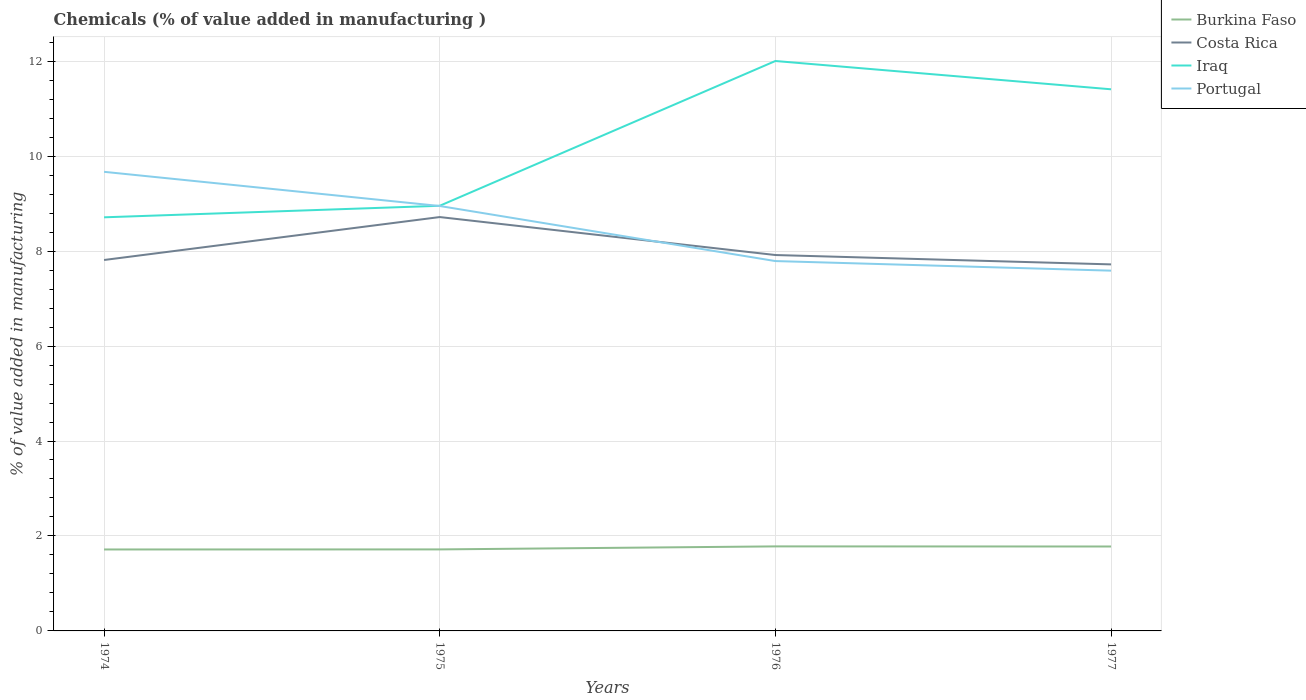Across all years, what is the maximum value added in manufacturing chemicals in Burkina Faso?
Ensure brevity in your answer.  1.72. In which year was the value added in manufacturing chemicals in Portugal maximum?
Offer a very short reply. 1977. What is the total value added in manufacturing chemicals in Iraq in the graph?
Ensure brevity in your answer.  0.6. What is the difference between the highest and the second highest value added in manufacturing chemicals in Iraq?
Your answer should be compact. 3.29. What is the difference between the highest and the lowest value added in manufacturing chemicals in Burkina Faso?
Your answer should be compact. 2. Are the values on the major ticks of Y-axis written in scientific E-notation?
Offer a terse response. No. Does the graph contain any zero values?
Make the answer very short. No. Where does the legend appear in the graph?
Your answer should be very brief. Top right. What is the title of the graph?
Give a very brief answer. Chemicals (% of value added in manufacturing ). What is the label or title of the X-axis?
Your answer should be compact. Years. What is the label or title of the Y-axis?
Make the answer very short. % of value added in manufacturing. What is the % of value added in manufacturing in Burkina Faso in 1974?
Keep it short and to the point. 1.72. What is the % of value added in manufacturing of Costa Rica in 1974?
Provide a succinct answer. 7.81. What is the % of value added in manufacturing of Iraq in 1974?
Keep it short and to the point. 8.71. What is the % of value added in manufacturing of Portugal in 1974?
Your answer should be compact. 9.67. What is the % of value added in manufacturing in Burkina Faso in 1975?
Your response must be concise. 1.72. What is the % of value added in manufacturing of Costa Rica in 1975?
Your answer should be very brief. 8.72. What is the % of value added in manufacturing in Iraq in 1975?
Your answer should be compact. 8.95. What is the % of value added in manufacturing of Portugal in 1975?
Provide a succinct answer. 8.95. What is the % of value added in manufacturing in Burkina Faso in 1976?
Provide a short and direct response. 1.78. What is the % of value added in manufacturing of Costa Rica in 1976?
Provide a succinct answer. 7.92. What is the % of value added in manufacturing in Iraq in 1976?
Provide a short and direct response. 12. What is the % of value added in manufacturing of Portugal in 1976?
Your answer should be very brief. 7.79. What is the % of value added in manufacturing in Burkina Faso in 1977?
Provide a succinct answer. 1.78. What is the % of value added in manufacturing of Costa Rica in 1977?
Offer a terse response. 7.72. What is the % of value added in manufacturing in Iraq in 1977?
Offer a very short reply. 11.41. What is the % of value added in manufacturing of Portugal in 1977?
Keep it short and to the point. 7.59. Across all years, what is the maximum % of value added in manufacturing of Burkina Faso?
Provide a succinct answer. 1.78. Across all years, what is the maximum % of value added in manufacturing in Costa Rica?
Keep it short and to the point. 8.72. Across all years, what is the maximum % of value added in manufacturing of Iraq?
Make the answer very short. 12. Across all years, what is the maximum % of value added in manufacturing of Portugal?
Your response must be concise. 9.67. Across all years, what is the minimum % of value added in manufacturing in Burkina Faso?
Provide a short and direct response. 1.72. Across all years, what is the minimum % of value added in manufacturing in Costa Rica?
Ensure brevity in your answer.  7.72. Across all years, what is the minimum % of value added in manufacturing in Iraq?
Give a very brief answer. 8.71. Across all years, what is the minimum % of value added in manufacturing of Portugal?
Your response must be concise. 7.59. What is the total % of value added in manufacturing in Burkina Faso in the graph?
Your answer should be very brief. 6.99. What is the total % of value added in manufacturing of Costa Rica in the graph?
Your answer should be very brief. 32.17. What is the total % of value added in manufacturing in Iraq in the graph?
Provide a succinct answer. 41.08. What is the total % of value added in manufacturing of Portugal in the graph?
Keep it short and to the point. 34. What is the difference between the % of value added in manufacturing in Burkina Faso in 1974 and that in 1975?
Offer a terse response. -0. What is the difference between the % of value added in manufacturing in Costa Rica in 1974 and that in 1975?
Provide a short and direct response. -0.9. What is the difference between the % of value added in manufacturing of Iraq in 1974 and that in 1975?
Offer a very short reply. -0.24. What is the difference between the % of value added in manufacturing in Portugal in 1974 and that in 1975?
Your answer should be very brief. 0.72. What is the difference between the % of value added in manufacturing of Burkina Faso in 1974 and that in 1976?
Provide a succinct answer. -0.06. What is the difference between the % of value added in manufacturing of Costa Rica in 1974 and that in 1976?
Keep it short and to the point. -0.1. What is the difference between the % of value added in manufacturing of Iraq in 1974 and that in 1976?
Provide a short and direct response. -3.29. What is the difference between the % of value added in manufacturing of Portugal in 1974 and that in 1976?
Your answer should be very brief. 1.88. What is the difference between the % of value added in manufacturing of Burkina Faso in 1974 and that in 1977?
Offer a very short reply. -0.06. What is the difference between the % of value added in manufacturing of Costa Rica in 1974 and that in 1977?
Make the answer very short. 0.09. What is the difference between the % of value added in manufacturing of Iraq in 1974 and that in 1977?
Offer a very short reply. -2.7. What is the difference between the % of value added in manufacturing of Portugal in 1974 and that in 1977?
Keep it short and to the point. 2.08. What is the difference between the % of value added in manufacturing of Burkina Faso in 1975 and that in 1976?
Your response must be concise. -0.06. What is the difference between the % of value added in manufacturing of Costa Rica in 1975 and that in 1976?
Provide a short and direct response. 0.8. What is the difference between the % of value added in manufacturing of Iraq in 1975 and that in 1976?
Keep it short and to the point. -3.05. What is the difference between the % of value added in manufacturing in Portugal in 1975 and that in 1976?
Provide a short and direct response. 1.16. What is the difference between the % of value added in manufacturing in Burkina Faso in 1975 and that in 1977?
Offer a very short reply. -0.06. What is the difference between the % of value added in manufacturing in Iraq in 1975 and that in 1977?
Your answer should be compact. -2.45. What is the difference between the % of value added in manufacturing in Portugal in 1975 and that in 1977?
Your answer should be very brief. 1.36. What is the difference between the % of value added in manufacturing in Burkina Faso in 1976 and that in 1977?
Offer a terse response. 0. What is the difference between the % of value added in manufacturing in Costa Rica in 1976 and that in 1977?
Your answer should be compact. 0.2. What is the difference between the % of value added in manufacturing in Iraq in 1976 and that in 1977?
Give a very brief answer. 0.6. What is the difference between the % of value added in manufacturing in Portugal in 1976 and that in 1977?
Ensure brevity in your answer.  0.2. What is the difference between the % of value added in manufacturing of Burkina Faso in 1974 and the % of value added in manufacturing of Costa Rica in 1975?
Provide a short and direct response. -7. What is the difference between the % of value added in manufacturing of Burkina Faso in 1974 and the % of value added in manufacturing of Iraq in 1975?
Provide a short and direct response. -7.24. What is the difference between the % of value added in manufacturing of Burkina Faso in 1974 and the % of value added in manufacturing of Portugal in 1975?
Keep it short and to the point. -7.23. What is the difference between the % of value added in manufacturing of Costa Rica in 1974 and the % of value added in manufacturing of Iraq in 1975?
Provide a short and direct response. -1.14. What is the difference between the % of value added in manufacturing in Costa Rica in 1974 and the % of value added in manufacturing in Portugal in 1975?
Your answer should be very brief. -1.14. What is the difference between the % of value added in manufacturing of Iraq in 1974 and the % of value added in manufacturing of Portugal in 1975?
Give a very brief answer. -0.24. What is the difference between the % of value added in manufacturing of Burkina Faso in 1974 and the % of value added in manufacturing of Costa Rica in 1976?
Keep it short and to the point. -6.2. What is the difference between the % of value added in manufacturing of Burkina Faso in 1974 and the % of value added in manufacturing of Iraq in 1976?
Offer a terse response. -10.29. What is the difference between the % of value added in manufacturing of Burkina Faso in 1974 and the % of value added in manufacturing of Portugal in 1976?
Your answer should be compact. -6.07. What is the difference between the % of value added in manufacturing in Costa Rica in 1974 and the % of value added in manufacturing in Iraq in 1976?
Your answer should be compact. -4.19. What is the difference between the % of value added in manufacturing in Costa Rica in 1974 and the % of value added in manufacturing in Portugal in 1976?
Make the answer very short. 0.02. What is the difference between the % of value added in manufacturing of Iraq in 1974 and the % of value added in manufacturing of Portugal in 1976?
Provide a short and direct response. 0.92. What is the difference between the % of value added in manufacturing in Burkina Faso in 1974 and the % of value added in manufacturing in Costa Rica in 1977?
Your response must be concise. -6. What is the difference between the % of value added in manufacturing of Burkina Faso in 1974 and the % of value added in manufacturing of Iraq in 1977?
Your answer should be compact. -9.69. What is the difference between the % of value added in manufacturing of Burkina Faso in 1974 and the % of value added in manufacturing of Portugal in 1977?
Your answer should be very brief. -5.87. What is the difference between the % of value added in manufacturing of Costa Rica in 1974 and the % of value added in manufacturing of Iraq in 1977?
Provide a succinct answer. -3.6. What is the difference between the % of value added in manufacturing in Costa Rica in 1974 and the % of value added in manufacturing in Portugal in 1977?
Make the answer very short. 0.22. What is the difference between the % of value added in manufacturing of Iraq in 1974 and the % of value added in manufacturing of Portugal in 1977?
Give a very brief answer. 1.12. What is the difference between the % of value added in manufacturing in Burkina Faso in 1975 and the % of value added in manufacturing in Costa Rica in 1976?
Provide a short and direct response. -6.2. What is the difference between the % of value added in manufacturing in Burkina Faso in 1975 and the % of value added in manufacturing in Iraq in 1976?
Ensure brevity in your answer.  -10.29. What is the difference between the % of value added in manufacturing of Burkina Faso in 1975 and the % of value added in manufacturing of Portugal in 1976?
Provide a succinct answer. -6.07. What is the difference between the % of value added in manufacturing in Costa Rica in 1975 and the % of value added in manufacturing in Iraq in 1976?
Offer a very short reply. -3.29. What is the difference between the % of value added in manufacturing in Costa Rica in 1975 and the % of value added in manufacturing in Portugal in 1976?
Offer a terse response. 0.93. What is the difference between the % of value added in manufacturing in Iraq in 1975 and the % of value added in manufacturing in Portugal in 1976?
Offer a terse response. 1.16. What is the difference between the % of value added in manufacturing of Burkina Faso in 1975 and the % of value added in manufacturing of Costa Rica in 1977?
Your answer should be very brief. -6. What is the difference between the % of value added in manufacturing in Burkina Faso in 1975 and the % of value added in manufacturing in Iraq in 1977?
Offer a very short reply. -9.69. What is the difference between the % of value added in manufacturing in Burkina Faso in 1975 and the % of value added in manufacturing in Portugal in 1977?
Provide a succinct answer. -5.87. What is the difference between the % of value added in manufacturing in Costa Rica in 1975 and the % of value added in manufacturing in Iraq in 1977?
Offer a very short reply. -2.69. What is the difference between the % of value added in manufacturing in Costa Rica in 1975 and the % of value added in manufacturing in Portugal in 1977?
Your response must be concise. 1.13. What is the difference between the % of value added in manufacturing of Iraq in 1975 and the % of value added in manufacturing of Portugal in 1977?
Give a very brief answer. 1.37. What is the difference between the % of value added in manufacturing in Burkina Faso in 1976 and the % of value added in manufacturing in Costa Rica in 1977?
Provide a short and direct response. -5.94. What is the difference between the % of value added in manufacturing of Burkina Faso in 1976 and the % of value added in manufacturing of Iraq in 1977?
Offer a terse response. -9.63. What is the difference between the % of value added in manufacturing of Burkina Faso in 1976 and the % of value added in manufacturing of Portugal in 1977?
Give a very brief answer. -5.81. What is the difference between the % of value added in manufacturing in Costa Rica in 1976 and the % of value added in manufacturing in Iraq in 1977?
Offer a terse response. -3.49. What is the difference between the % of value added in manufacturing of Costa Rica in 1976 and the % of value added in manufacturing of Portugal in 1977?
Your answer should be compact. 0.33. What is the difference between the % of value added in manufacturing of Iraq in 1976 and the % of value added in manufacturing of Portugal in 1977?
Give a very brief answer. 4.42. What is the average % of value added in manufacturing in Burkina Faso per year?
Offer a terse response. 1.75. What is the average % of value added in manufacturing in Costa Rica per year?
Give a very brief answer. 8.04. What is the average % of value added in manufacturing of Iraq per year?
Make the answer very short. 10.27. What is the average % of value added in manufacturing in Portugal per year?
Provide a short and direct response. 8.5. In the year 1974, what is the difference between the % of value added in manufacturing of Burkina Faso and % of value added in manufacturing of Costa Rica?
Your answer should be very brief. -6.1. In the year 1974, what is the difference between the % of value added in manufacturing of Burkina Faso and % of value added in manufacturing of Iraq?
Make the answer very short. -7. In the year 1974, what is the difference between the % of value added in manufacturing in Burkina Faso and % of value added in manufacturing in Portugal?
Offer a terse response. -7.95. In the year 1974, what is the difference between the % of value added in manufacturing of Costa Rica and % of value added in manufacturing of Iraq?
Ensure brevity in your answer.  -0.9. In the year 1974, what is the difference between the % of value added in manufacturing in Costa Rica and % of value added in manufacturing in Portugal?
Make the answer very short. -1.86. In the year 1974, what is the difference between the % of value added in manufacturing in Iraq and % of value added in manufacturing in Portugal?
Offer a terse response. -0.96. In the year 1975, what is the difference between the % of value added in manufacturing of Burkina Faso and % of value added in manufacturing of Costa Rica?
Give a very brief answer. -7. In the year 1975, what is the difference between the % of value added in manufacturing in Burkina Faso and % of value added in manufacturing in Iraq?
Your answer should be very brief. -7.24. In the year 1975, what is the difference between the % of value added in manufacturing in Burkina Faso and % of value added in manufacturing in Portugal?
Your response must be concise. -7.23. In the year 1975, what is the difference between the % of value added in manufacturing in Costa Rica and % of value added in manufacturing in Iraq?
Provide a short and direct response. -0.24. In the year 1975, what is the difference between the % of value added in manufacturing of Costa Rica and % of value added in manufacturing of Portugal?
Provide a succinct answer. -0.23. In the year 1975, what is the difference between the % of value added in manufacturing of Iraq and % of value added in manufacturing of Portugal?
Provide a short and direct response. 0. In the year 1976, what is the difference between the % of value added in manufacturing of Burkina Faso and % of value added in manufacturing of Costa Rica?
Your response must be concise. -6.14. In the year 1976, what is the difference between the % of value added in manufacturing in Burkina Faso and % of value added in manufacturing in Iraq?
Your response must be concise. -10.22. In the year 1976, what is the difference between the % of value added in manufacturing in Burkina Faso and % of value added in manufacturing in Portugal?
Your answer should be very brief. -6.01. In the year 1976, what is the difference between the % of value added in manufacturing of Costa Rica and % of value added in manufacturing of Iraq?
Give a very brief answer. -4.09. In the year 1976, what is the difference between the % of value added in manufacturing of Costa Rica and % of value added in manufacturing of Portugal?
Offer a terse response. 0.13. In the year 1976, what is the difference between the % of value added in manufacturing of Iraq and % of value added in manufacturing of Portugal?
Your response must be concise. 4.21. In the year 1977, what is the difference between the % of value added in manufacturing in Burkina Faso and % of value added in manufacturing in Costa Rica?
Give a very brief answer. -5.94. In the year 1977, what is the difference between the % of value added in manufacturing of Burkina Faso and % of value added in manufacturing of Iraq?
Provide a short and direct response. -9.63. In the year 1977, what is the difference between the % of value added in manufacturing in Burkina Faso and % of value added in manufacturing in Portugal?
Make the answer very short. -5.81. In the year 1977, what is the difference between the % of value added in manufacturing of Costa Rica and % of value added in manufacturing of Iraq?
Give a very brief answer. -3.69. In the year 1977, what is the difference between the % of value added in manufacturing of Costa Rica and % of value added in manufacturing of Portugal?
Make the answer very short. 0.13. In the year 1977, what is the difference between the % of value added in manufacturing of Iraq and % of value added in manufacturing of Portugal?
Offer a terse response. 3.82. What is the ratio of the % of value added in manufacturing in Burkina Faso in 1974 to that in 1975?
Offer a terse response. 1. What is the ratio of the % of value added in manufacturing in Costa Rica in 1974 to that in 1975?
Keep it short and to the point. 0.9. What is the ratio of the % of value added in manufacturing in Iraq in 1974 to that in 1975?
Make the answer very short. 0.97. What is the ratio of the % of value added in manufacturing in Portugal in 1974 to that in 1975?
Ensure brevity in your answer.  1.08. What is the ratio of the % of value added in manufacturing of Burkina Faso in 1974 to that in 1976?
Keep it short and to the point. 0.96. What is the ratio of the % of value added in manufacturing in Costa Rica in 1974 to that in 1976?
Provide a succinct answer. 0.99. What is the ratio of the % of value added in manufacturing in Iraq in 1974 to that in 1976?
Your response must be concise. 0.73. What is the ratio of the % of value added in manufacturing of Portugal in 1974 to that in 1976?
Your answer should be very brief. 1.24. What is the ratio of the % of value added in manufacturing of Burkina Faso in 1974 to that in 1977?
Give a very brief answer. 0.96. What is the ratio of the % of value added in manufacturing in Iraq in 1974 to that in 1977?
Your answer should be very brief. 0.76. What is the ratio of the % of value added in manufacturing in Portugal in 1974 to that in 1977?
Make the answer very short. 1.27. What is the ratio of the % of value added in manufacturing of Costa Rica in 1975 to that in 1976?
Ensure brevity in your answer.  1.1. What is the ratio of the % of value added in manufacturing in Iraq in 1975 to that in 1976?
Provide a short and direct response. 0.75. What is the ratio of the % of value added in manufacturing in Portugal in 1975 to that in 1976?
Your answer should be compact. 1.15. What is the ratio of the % of value added in manufacturing of Burkina Faso in 1975 to that in 1977?
Ensure brevity in your answer.  0.97. What is the ratio of the % of value added in manufacturing in Costa Rica in 1975 to that in 1977?
Give a very brief answer. 1.13. What is the ratio of the % of value added in manufacturing of Iraq in 1975 to that in 1977?
Offer a very short reply. 0.78. What is the ratio of the % of value added in manufacturing of Portugal in 1975 to that in 1977?
Give a very brief answer. 1.18. What is the ratio of the % of value added in manufacturing of Burkina Faso in 1976 to that in 1977?
Your answer should be very brief. 1. What is the ratio of the % of value added in manufacturing of Costa Rica in 1976 to that in 1977?
Provide a short and direct response. 1.03. What is the ratio of the % of value added in manufacturing in Iraq in 1976 to that in 1977?
Make the answer very short. 1.05. What is the ratio of the % of value added in manufacturing of Portugal in 1976 to that in 1977?
Make the answer very short. 1.03. What is the difference between the highest and the second highest % of value added in manufacturing of Burkina Faso?
Your answer should be very brief. 0. What is the difference between the highest and the second highest % of value added in manufacturing in Costa Rica?
Provide a succinct answer. 0.8. What is the difference between the highest and the second highest % of value added in manufacturing in Iraq?
Your answer should be compact. 0.6. What is the difference between the highest and the second highest % of value added in manufacturing in Portugal?
Provide a short and direct response. 0.72. What is the difference between the highest and the lowest % of value added in manufacturing of Burkina Faso?
Offer a very short reply. 0.06. What is the difference between the highest and the lowest % of value added in manufacturing of Costa Rica?
Provide a short and direct response. 1. What is the difference between the highest and the lowest % of value added in manufacturing of Iraq?
Provide a succinct answer. 3.29. What is the difference between the highest and the lowest % of value added in manufacturing of Portugal?
Your response must be concise. 2.08. 